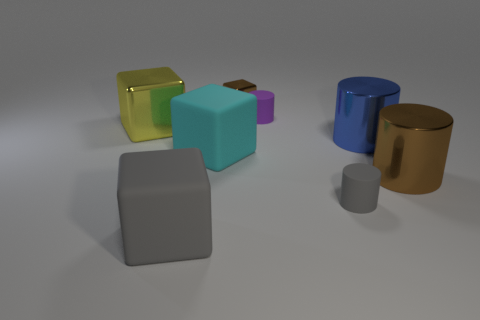What number of objects are either yellow cubes or cubes left of the small shiny block?
Offer a terse response. 3. There is a gray object left of the brown cube; is it the same size as the brown cylinder?
Ensure brevity in your answer.  Yes. How many big cyan rubber things are to the right of the brown object behind the metallic object that is on the left side of the gray block?
Provide a succinct answer. 0. What number of brown things are either large shiny blocks or matte blocks?
Your response must be concise. 0. The small thing that is the same material as the big brown cylinder is what color?
Your answer should be very brief. Brown. What number of tiny objects are either rubber blocks or cyan rubber cubes?
Provide a short and direct response. 0. Are there fewer tiny metal things than shiny cylinders?
Your answer should be very brief. Yes. What is the color of the large metal object that is the same shape as the small metallic thing?
Offer a terse response. Yellow. Are there more large brown metal objects than brown metallic objects?
Ensure brevity in your answer.  No. How many other objects are the same material as the cyan block?
Offer a very short reply. 3. 